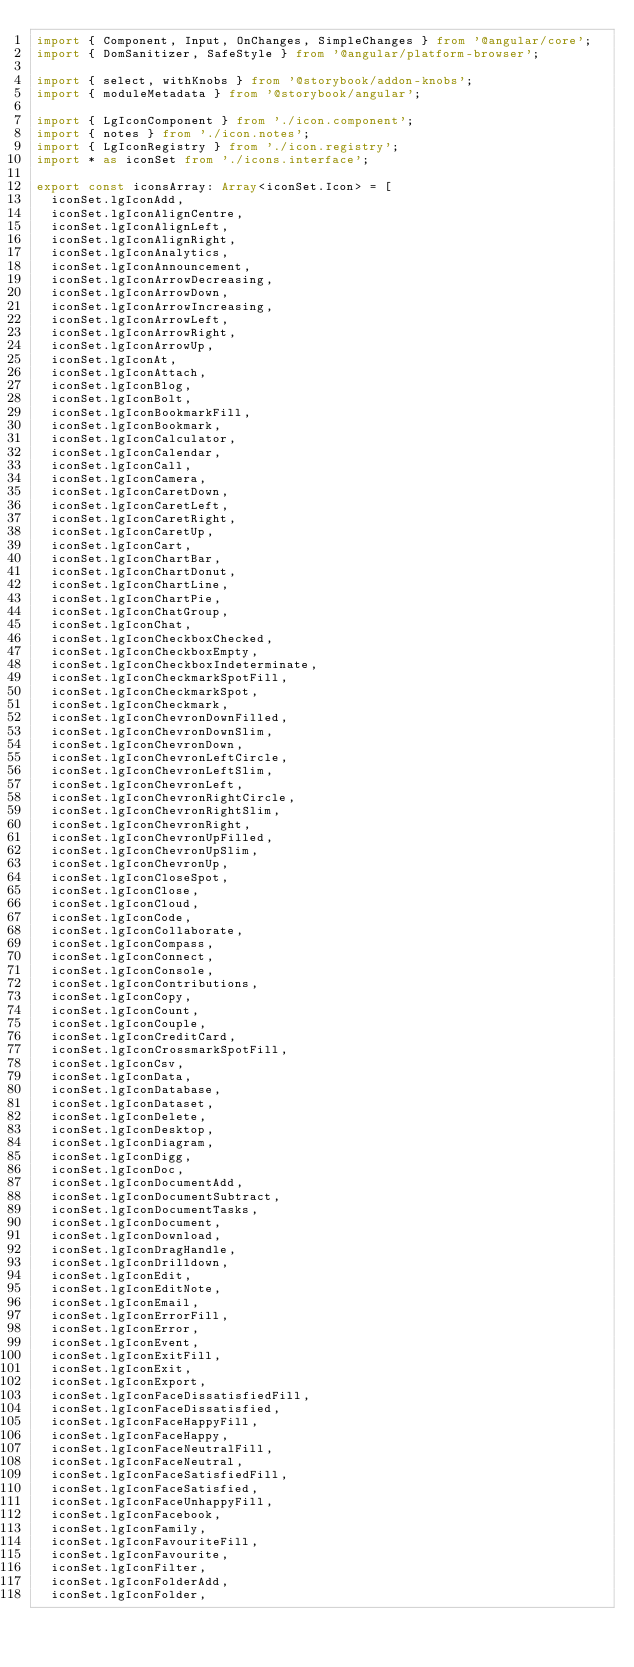Convert code to text. <code><loc_0><loc_0><loc_500><loc_500><_TypeScript_>import { Component, Input, OnChanges, SimpleChanges } from '@angular/core';
import { DomSanitizer, SafeStyle } from '@angular/platform-browser';

import { select, withKnobs } from '@storybook/addon-knobs';
import { moduleMetadata } from '@storybook/angular';

import { LgIconComponent } from './icon.component';
import { notes } from './icon.notes';
import { LgIconRegistry } from './icon.registry';
import * as iconSet from './icons.interface';

export const iconsArray: Array<iconSet.Icon> = [
  iconSet.lgIconAdd,
  iconSet.lgIconAlignCentre,
  iconSet.lgIconAlignLeft,
  iconSet.lgIconAlignRight,
  iconSet.lgIconAnalytics,
  iconSet.lgIconAnnouncement,
  iconSet.lgIconArrowDecreasing,
  iconSet.lgIconArrowDown,
  iconSet.lgIconArrowIncreasing,
  iconSet.lgIconArrowLeft,
  iconSet.lgIconArrowRight,
  iconSet.lgIconArrowUp,
  iconSet.lgIconAt,
  iconSet.lgIconAttach,
  iconSet.lgIconBlog,
  iconSet.lgIconBolt,
  iconSet.lgIconBookmarkFill,
  iconSet.lgIconBookmark,
  iconSet.lgIconCalculator,
  iconSet.lgIconCalendar,
  iconSet.lgIconCall,
  iconSet.lgIconCamera,
  iconSet.lgIconCaretDown,
  iconSet.lgIconCaretLeft,
  iconSet.lgIconCaretRight,
  iconSet.lgIconCaretUp,
  iconSet.lgIconCart,
  iconSet.lgIconChartBar,
  iconSet.lgIconChartDonut,
  iconSet.lgIconChartLine,
  iconSet.lgIconChartPie,
  iconSet.lgIconChatGroup,
  iconSet.lgIconChat,
  iconSet.lgIconCheckboxChecked,
  iconSet.lgIconCheckboxEmpty,
  iconSet.lgIconCheckboxIndeterminate,
  iconSet.lgIconCheckmarkSpotFill,
  iconSet.lgIconCheckmarkSpot,
  iconSet.lgIconCheckmark,
  iconSet.lgIconChevronDownFilled,
  iconSet.lgIconChevronDownSlim,
  iconSet.lgIconChevronDown,
  iconSet.lgIconChevronLeftCircle,
  iconSet.lgIconChevronLeftSlim,
  iconSet.lgIconChevronLeft,
  iconSet.lgIconChevronRightCircle,
  iconSet.lgIconChevronRightSlim,
  iconSet.lgIconChevronRight,
  iconSet.lgIconChevronUpFilled,
  iconSet.lgIconChevronUpSlim,
  iconSet.lgIconChevronUp,
  iconSet.lgIconCloseSpot,
  iconSet.lgIconClose,
  iconSet.lgIconCloud,
  iconSet.lgIconCode,
  iconSet.lgIconCollaborate,
  iconSet.lgIconCompass,
  iconSet.lgIconConnect,
  iconSet.lgIconConsole,
  iconSet.lgIconContributions,
  iconSet.lgIconCopy,
  iconSet.lgIconCount,
  iconSet.lgIconCouple,
  iconSet.lgIconCreditCard,
  iconSet.lgIconCrossmarkSpotFill,
  iconSet.lgIconCsv,
  iconSet.lgIconData,
  iconSet.lgIconDatabase,
  iconSet.lgIconDataset,
  iconSet.lgIconDelete,
  iconSet.lgIconDesktop,
  iconSet.lgIconDiagram,
  iconSet.lgIconDigg,
  iconSet.lgIconDoc,
  iconSet.lgIconDocumentAdd,
  iconSet.lgIconDocumentSubtract,
  iconSet.lgIconDocumentTasks,
  iconSet.lgIconDocument,
  iconSet.lgIconDownload,
  iconSet.lgIconDragHandle,
  iconSet.lgIconDrilldown,
  iconSet.lgIconEdit,
  iconSet.lgIconEditNote,
  iconSet.lgIconEmail,
  iconSet.lgIconErrorFill,
  iconSet.lgIconError,
  iconSet.lgIconEvent,
  iconSet.lgIconExitFill,
  iconSet.lgIconExit,
  iconSet.lgIconExport,
  iconSet.lgIconFaceDissatisfiedFill,
  iconSet.lgIconFaceDissatisfied,
  iconSet.lgIconFaceHappyFill,
  iconSet.lgIconFaceHappy,
  iconSet.lgIconFaceNeutralFill,
  iconSet.lgIconFaceNeutral,
  iconSet.lgIconFaceSatisfiedFill,
  iconSet.lgIconFaceSatisfied,
  iconSet.lgIconFaceUnhappyFill,
  iconSet.lgIconFacebook,
  iconSet.lgIconFamily,
  iconSet.lgIconFavouriteFill,
  iconSet.lgIconFavourite,
  iconSet.lgIconFilter,
  iconSet.lgIconFolderAdd,
  iconSet.lgIconFolder,</code> 